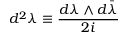<formula> <loc_0><loc_0><loc_500><loc_500>d ^ { 2 } \lambda \equiv \frac { d \lambda \wedge d \bar { \lambda } } { 2 i }</formula> 